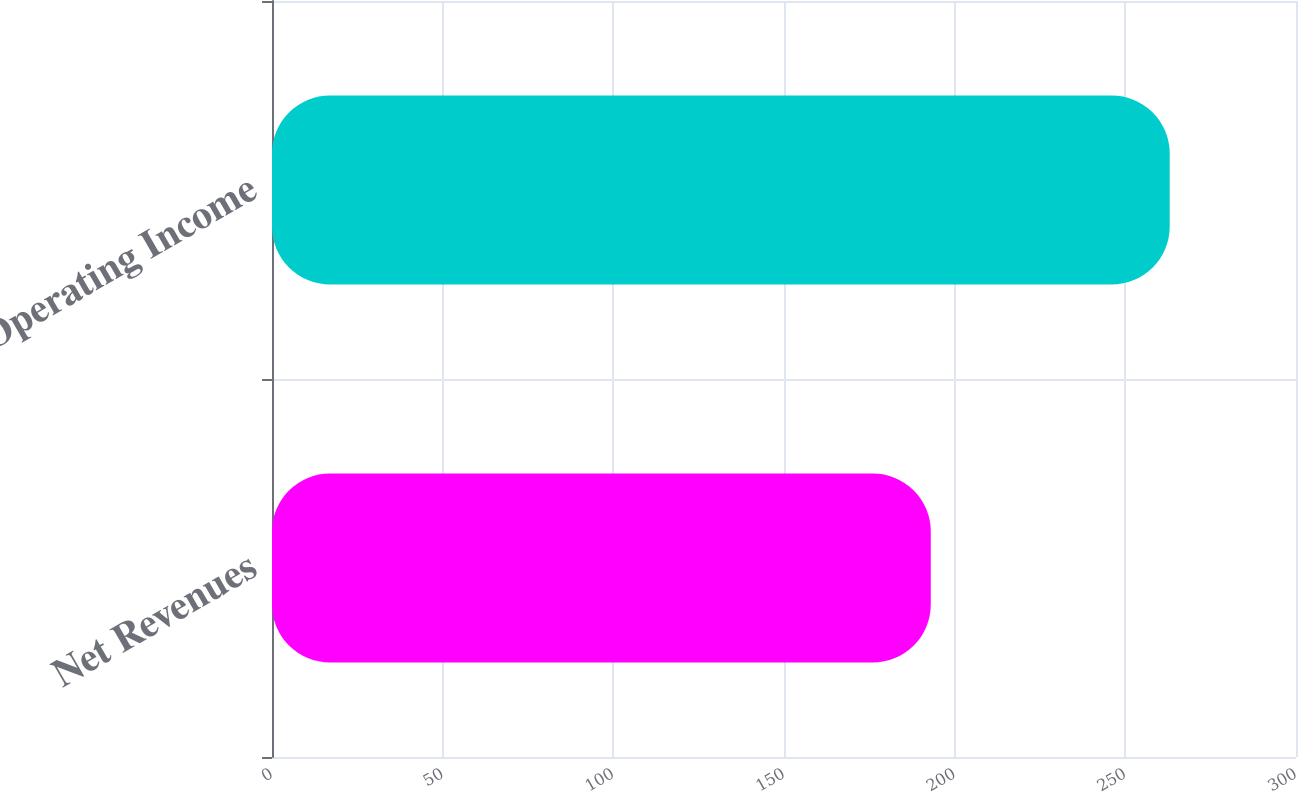Convert chart. <chart><loc_0><loc_0><loc_500><loc_500><bar_chart><fcel>Net Revenues<fcel>Operating Income<nl><fcel>193<fcel>263<nl></chart> 